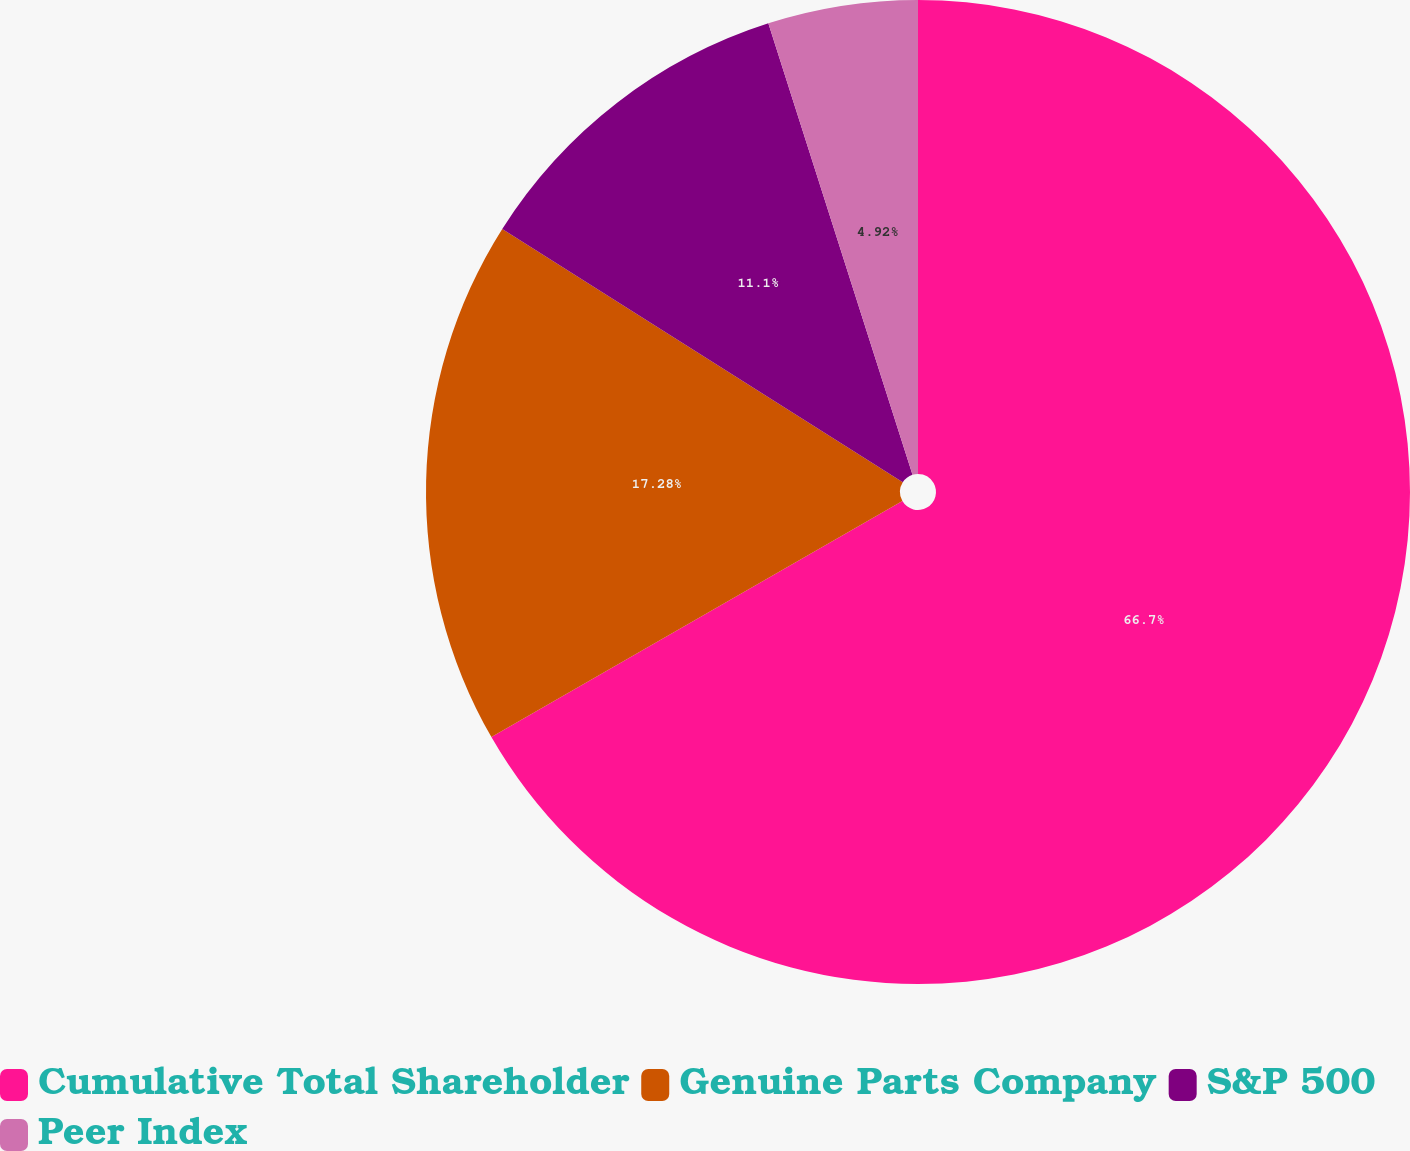<chart> <loc_0><loc_0><loc_500><loc_500><pie_chart><fcel>Cumulative Total Shareholder<fcel>Genuine Parts Company<fcel>S&P 500<fcel>Peer Index<nl><fcel>66.7%<fcel>17.28%<fcel>11.1%<fcel>4.92%<nl></chart> 